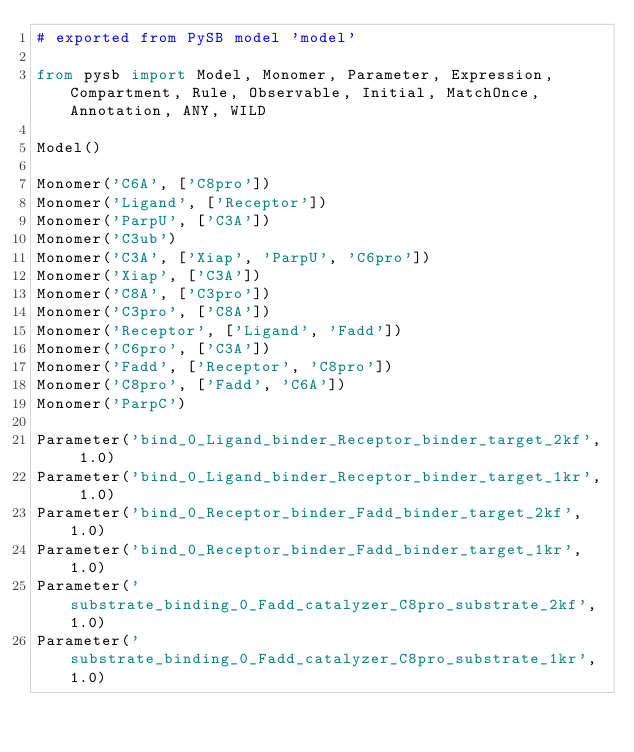Convert code to text. <code><loc_0><loc_0><loc_500><loc_500><_Python_># exported from PySB model 'model'

from pysb import Model, Monomer, Parameter, Expression, Compartment, Rule, Observable, Initial, MatchOnce, Annotation, ANY, WILD

Model()

Monomer('C6A', ['C8pro'])
Monomer('Ligand', ['Receptor'])
Monomer('ParpU', ['C3A'])
Monomer('C3ub')
Monomer('C3A', ['Xiap', 'ParpU', 'C6pro'])
Monomer('Xiap', ['C3A'])
Monomer('C8A', ['C3pro'])
Monomer('C3pro', ['C8A'])
Monomer('Receptor', ['Ligand', 'Fadd'])
Monomer('C6pro', ['C3A'])
Monomer('Fadd', ['Receptor', 'C8pro'])
Monomer('C8pro', ['Fadd', 'C6A'])
Monomer('ParpC')

Parameter('bind_0_Ligand_binder_Receptor_binder_target_2kf', 1.0)
Parameter('bind_0_Ligand_binder_Receptor_binder_target_1kr', 1.0)
Parameter('bind_0_Receptor_binder_Fadd_binder_target_2kf', 1.0)
Parameter('bind_0_Receptor_binder_Fadd_binder_target_1kr', 1.0)
Parameter('substrate_binding_0_Fadd_catalyzer_C8pro_substrate_2kf', 1.0)
Parameter('substrate_binding_0_Fadd_catalyzer_C8pro_substrate_1kr', 1.0)</code> 